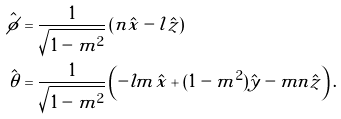Convert formula to latex. <formula><loc_0><loc_0><loc_500><loc_500>\hat { \phi } & = \frac { 1 } { \sqrt { 1 - m ^ { 2 } } } \left ( n \hat { x } - l \hat { z } \right ) \\ \hat { \theta } & = \frac { 1 } { \sqrt { 1 - m ^ { 2 } } } \left ( - l m \hat { x } + ( 1 - m ^ { 2 } ) \hat { y } - m n \hat { z } \right ) .</formula> 